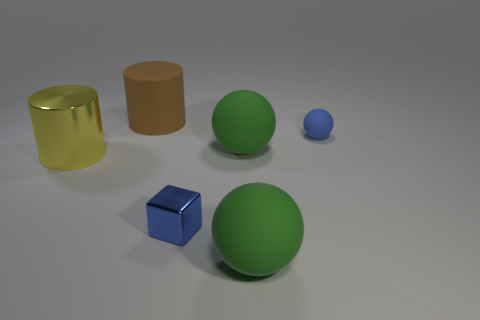Is there a big sphere that has the same material as the brown cylinder? yes 